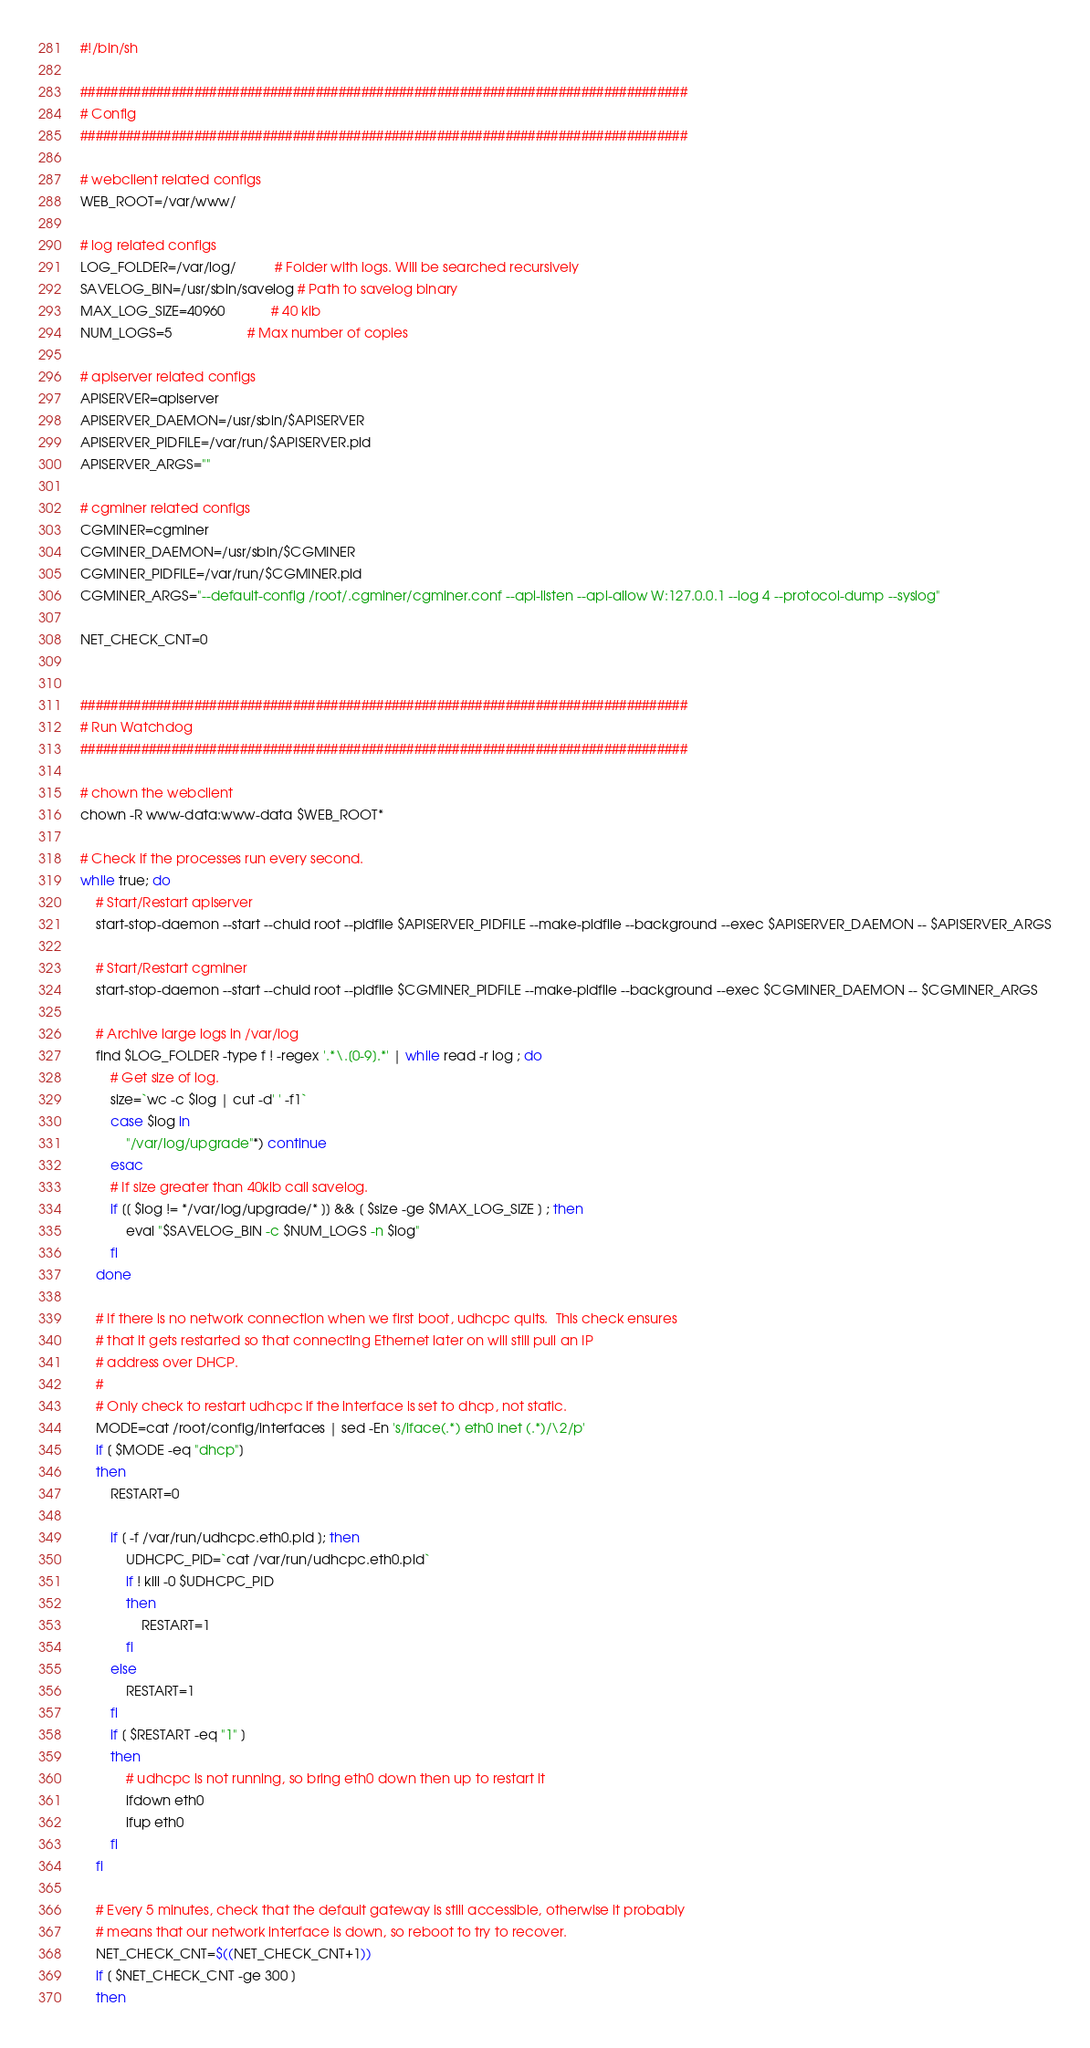<code> <loc_0><loc_0><loc_500><loc_500><_Bash_>#!/bin/sh

################################################################################
# Config
################################################################################

# webclient related configs
WEB_ROOT=/var/www/

# log related configs
LOG_FOLDER=/var/log/          # Folder with logs. Will be searched recursively
SAVELOG_BIN=/usr/sbin/savelog # Path to savelog binary
MAX_LOG_SIZE=40960            # 40 kib
NUM_LOGS=5                    # Max number of copies

# apiserver related configs
APISERVER=apiserver
APISERVER_DAEMON=/usr/sbin/$APISERVER
APISERVER_PIDFILE=/var/run/$APISERVER.pid
APISERVER_ARGS=""

# cgminer related configs
CGMINER=cgminer
CGMINER_DAEMON=/usr/sbin/$CGMINER
CGMINER_PIDFILE=/var/run/$CGMINER.pid
CGMINER_ARGS="--default-config /root/.cgminer/cgminer.conf --api-listen --api-allow W:127.0.0.1 --log 4 --protocol-dump --syslog"

NET_CHECK_CNT=0


################################################################################
# Run Watchdog
################################################################################

# chown the webclient
chown -R www-data:www-data $WEB_ROOT*

# Check if the processes run every second.
while true; do
	# Start/Restart apiserver
	start-stop-daemon --start --chuid root --pidfile $APISERVER_PIDFILE --make-pidfile --background --exec $APISERVER_DAEMON -- $APISERVER_ARGS

	# Start/Restart cgminer
	start-stop-daemon --start --chuid root --pidfile $CGMINER_PIDFILE --make-pidfile --background --exec $CGMINER_DAEMON -- $CGMINER_ARGS

	# Archive large logs in /var/log
	find $LOG_FOLDER -type f ! -regex '.*\.[0-9].*' | while read -r log ; do
		# Get size of log.
		size=`wc -c $log | cut -d' ' -f1`
		case $log in
			"/var/log/upgrade"*) continue
		esac
		# If size greater than 40kib call savelog.
		if [[ $log != */var/log/upgrade/* ]] && [ $size -ge $MAX_LOG_SIZE ] ; then
			eval "$SAVELOG_BIN -c $NUM_LOGS -n $log"
		fi
	done

	# If there is no network connection when we first boot, udhcpc quits.  This check ensures
	# that it gets restarted so that connecting Ethernet later on will still pull an IP
	# address over DHCP.
	#
	# Only check to restart udhcpc if the interface is set to dhcp, not static.
	MODE=cat /root/config/interfaces | sed -En 's/iface(.*) eth0 inet (.*)/\2/p'
	if [ $MODE -eq "dhcp"]
	then
		RESTART=0
	
		if [ -f /var/run/udhcpc.eth0.pid ]; then
			UDHCPC_PID=`cat /var/run/udhcpc.eth0.pid`
			if ! kill -0 $UDHCPC_PID
			then
				RESTART=1
			fi
		else
			RESTART=1
		fi
		if [ $RESTART -eq "1" ]
		then
			# udhcpc is not running, so bring eth0 down then up to restart it
			ifdown eth0
			ifup eth0
		fi
	fi

	# Every 5 minutes, check that the default gateway is still accessible, otherwise it probably
	# means that our network interface is down, so reboot to try to recover.
	NET_CHECK_CNT=$((NET_CHECK_CNT+1))
	if [ $NET_CHECK_CNT -ge 300 ]
	then</code> 